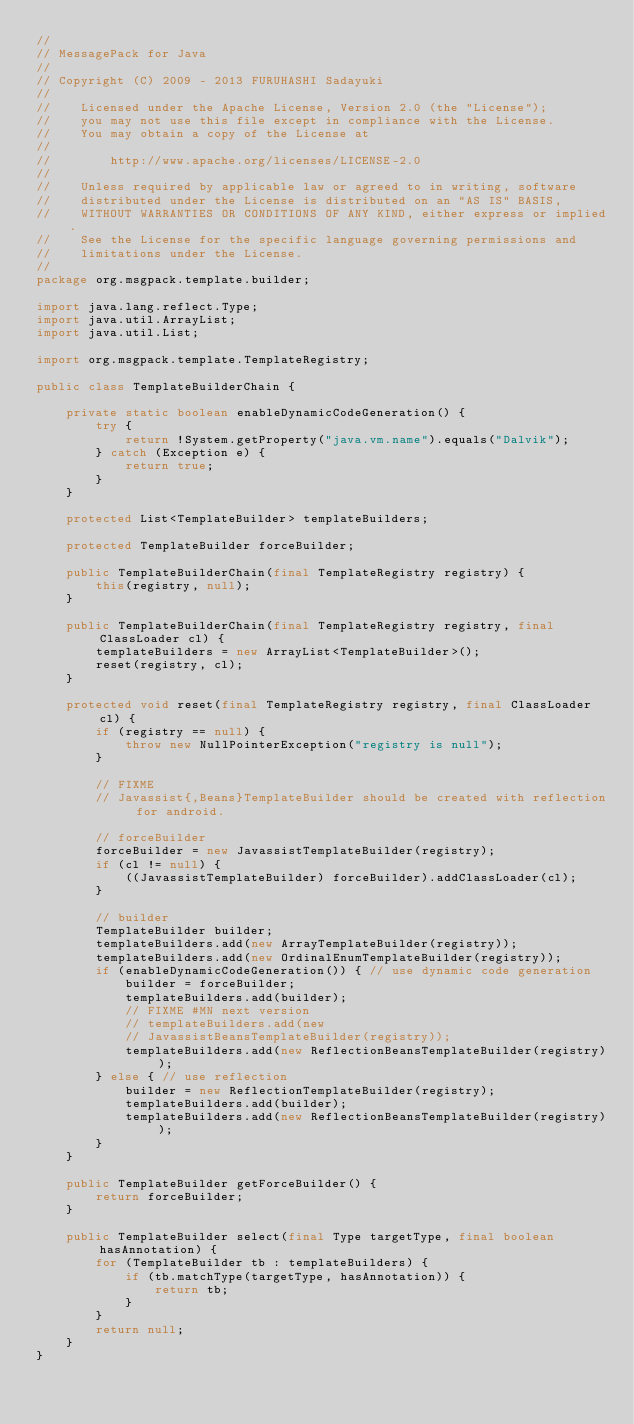Convert code to text. <code><loc_0><loc_0><loc_500><loc_500><_Java_>//
// MessagePack for Java
//
// Copyright (C) 2009 - 2013 FURUHASHI Sadayuki
//
//    Licensed under the Apache License, Version 2.0 (the "License");
//    you may not use this file except in compliance with the License.
//    You may obtain a copy of the License at
//
//        http://www.apache.org/licenses/LICENSE-2.0
//
//    Unless required by applicable law or agreed to in writing, software
//    distributed under the License is distributed on an "AS IS" BASIS,
//    WITHOUT WARRANTIES OR CONDITIONS OF ANY KIND, either express or implied.
//    See the License for the specific language governing permissions and
//    limitations under the License.
//
package org.msgpack.template.builder;

import java.lang.reflect.Type;
import java.util.ArrayList;
import java.util.List;

import org.msgpack.template.TemplateRegistry;

public class TemplateBuilderChain {

    private static boolean enableDynamicCodeGeneration() {
        try {
            return !System.getProperty("java.vm.name").equals("Dalvik");
        } catch (Exception e) {
            return true;
        }
    }

    protected List<TemplateBuilder> templateBuilders;

    protected TemplateBuilder forceBuilder;

    public TemplateBuilderChain(final TemplateRegistry registry) {
        this(registry, null);
    }

    public TemplateBuilderChain(final TemplateRegistry registry, final ClassLoader cl) {
        templateBuilders = new ArrayList<TemplateBuilder>();
        reset(registry, cl);
    }

    protected void reset(final TemplateRegistry registry, final ClassLoader cl) {
        if (registry == null) {
            throw new NullPointerException("registry is null");
        }

        // FIXME
        // Javassist{,Beans}TemplateBuilder should be created with reflection for android.

        // forceBuilder
        forceBuilder = new JavassistTemplateBuilder(registry);
        if (cl != null) {
            ((JavassistTemplateBuilder) forceBuilder).addClassLoader(cl);
        }

        // builder
        TemplateBuilder builder;
        templateBuilders.add(new ArrayTemplateBuilder(registry));
        templateBuilders.add(new OrdinalEnumTemplateBuilder(registry));
        if (enableDynamicCodeGeneration()) { // use dynamic code generation
            builder = forceBuilder;
            templateBuilders.add(builder);
            // FIXME #MN next version
            // templateBuilders.add(new
            // JavassistBeansTemplateBuilder(registry));
            templateBuilders.add(new ReflectionBeansTemplateBuilder(registry));
        } else { // use reflection
            builder = new ReflectionTemplateBuilder(registry);
            templateBuilders.add(builder);
            templateBuilders.add(new ReflectionBeansTemplateBuilder(registry));
        }
    }

    public TemplateBuilder getForceBuilder() {
        return forceBuilder;
    }

    public TemplateBuilder select(final Type targetType, final boolean hasAnnotation) {
        for (TemplateBuilder tb : templateBuilders) {
            if (tb.matchType(targetType, hasAnnotation)) {
                return tb;
            }
        }
        return null;
    }
}
</code> 